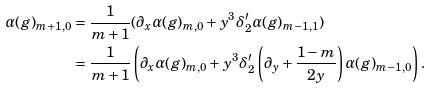<formula> <loc_0><loc_0><loc_500><loc_500>\alpha ( g ) _ { m + 1 , 0 } & = \frac { 1 } { m + 1 } ( \partial _ { x } \alpha ( g ) _ { m , 0 } + y ^ { 3 } \delta _ { 2 } ^ { \prime } \alpha ( g ) _ { m - 1 , 1 } ) \\ & = \frac { 1 } { m + 1 } \left ( \partial _ { x } \alpha ( g ) _ { m , 0 } + y ^ { 3 } \delta _ { 2 } ^ { \prime } \left ( \partial _ { y } + \frac { 1 - m } { 2 y } \right ) \alpha ( g ) _ { m - 1 , 0 } \right ) .</formula> 